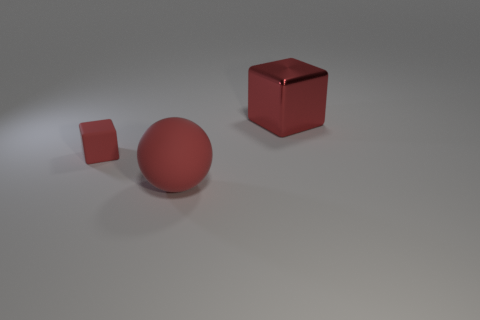Add 1 tiny yellow metallic objects. How many objects exist? 4 Subtract all cubes. How many objects are left? 1 Subtract 0 purple cubes. How many objects are left? 3 Subtract all large purple blocks. Subtract all tiny red rubber cubes. How many objects are left? 2 Add 2 matte things. How many matte things are left? 4 Add 3 large balls. How many large balls exist? 4 